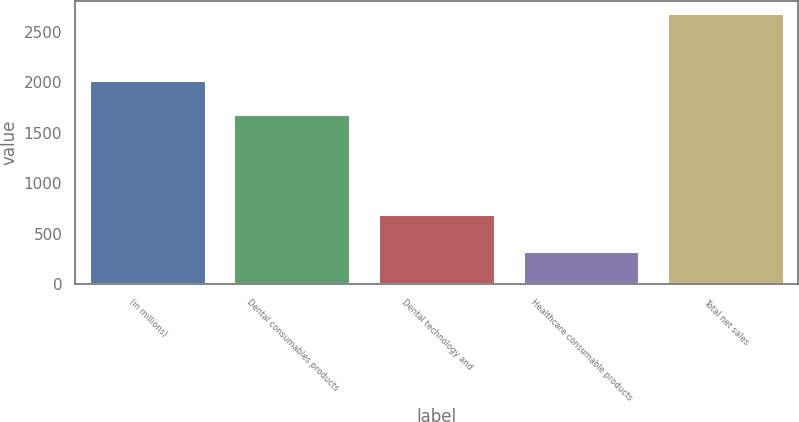<chart> <loc_0><loc_0><loc_500><loc_500><bar_chart><fcel>(in millions)<fcel>Dental consumables products<fcel>Dental technology and<fcel>Healthcare consumable products<fcel>Total net sales<nl><fcel>2015<fcel>1671.1<fcel>687.7<fcel>315.5<fcel>2674.3<nl></chart> 